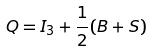<formula> <loc_0><loc_0><loc_500><loc_500>Q = I _ { 3 } + \frac { 1 } { 2 } ( B + S )</formula> 